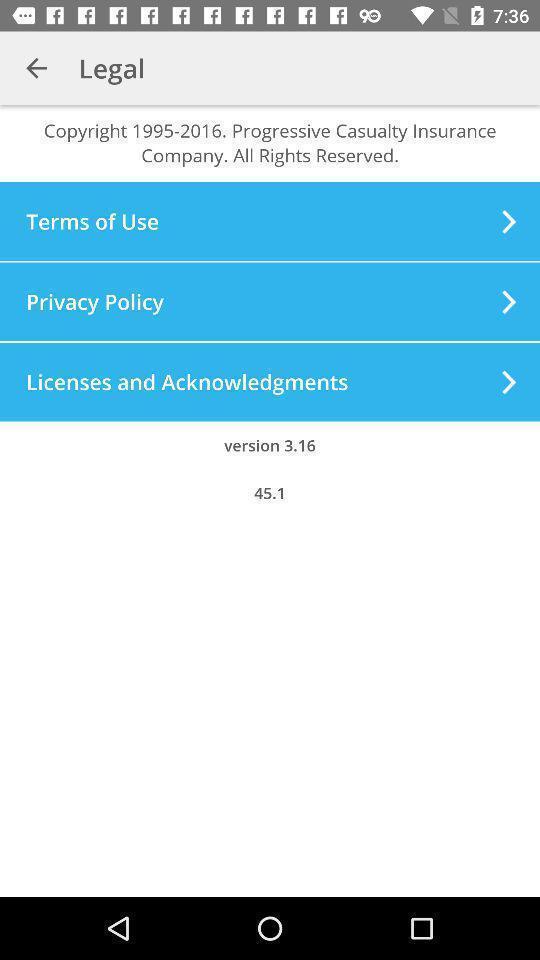What is the overall content of this screenshot? Page displaying legal terms and conditions. 